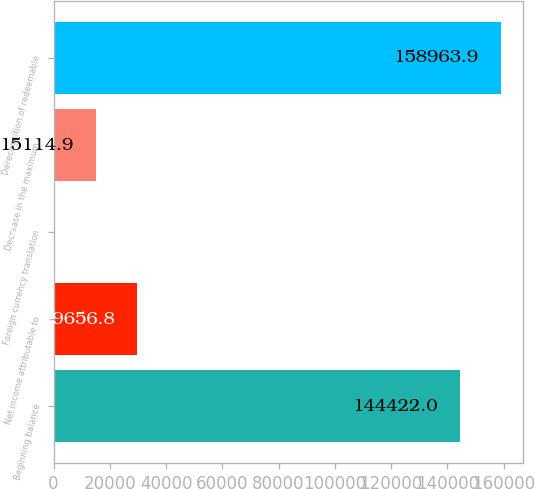<chart> <loc_0><loc_0><loc_500><loc_500><bar_chart><fcel>Beginning balance<fcel>Net income attributable to<fcel>Foreign currency translation<fcel>Decrease in the maximum<fcel>Derecognition of redeemable<nl><fcel>144422<fcel>29656.8<fcel>573<fcel>15114.9<fcel>158964<nl></chart> 